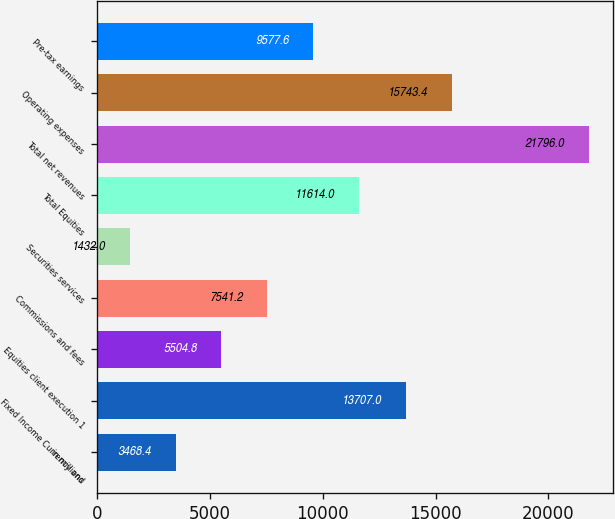Convert chart to OTSL. <chart><loc_0><loc_0><loc_500><loc_500><bar_chart><fcel>in millions<fcel>Fixed Income Currency and<fcel>Equities client execution 1<fcel>Commissions and fees<fcel>Securities services<fcel>Total Equities<fcel>Total net revenues<fcel>Operating expenses<fcel>Pre-tax earnings<nl><fcel>3468.4<fcel>13707<fcel>5504.8<fcel>7541.2<fcel>1432<fcel>11614<fcel>21796<fcel>15743.4<fcel>9577.6<nl></chart> 